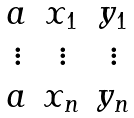<formula> <loc_0><loc_0><loc_500><loc_500>\begin{matrix} a & x _ { 1 } & y _ { 1 } \\ \vdots & \vdots & \vdots \\ a & x _ { n } & y _ { n } \end{matrix}</formula> 